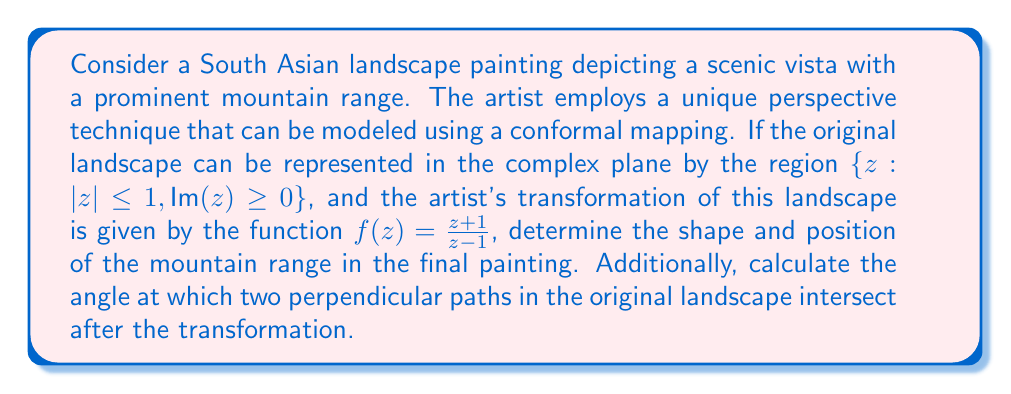Provide a solution to this math problem. To analyze this problem, we'll follow these steps:

1) First, let's understand the original region:
   $\{z: |z| \leq 1, \text{Im}(z) \geq 0\}$ represents the upper half of the unit circle in the complex plane.

2) The conformal mapping $f(z) = \frac{z+1}{z-1}$ is a Möbius transformation. This transformation has some key properties:
   - It maps circles and lines to circles or lines.
   - It preserves angles between curves.

3) To determine the shape of the transformed region, we need to map key points:
   - The point $z=i$ maps to $f(i) = \frac{i+1}{i-1} = i$
   - The point $z=-1$ maps to $f(-1) = 0$
   - The point $z=1$ maps to $f(1) = \infty$

4) The semicircle $|z|=1$ in the upper half-plane maps to the imaginary axis from 0 to $\infty$.

5) The diameter of the semicircle on the real axis from -1 to 1 maps to the entire real axis.

6) Therefore, the transformed region is the right half-plane, $\{w: \text{Re}(w) > 0\}$.

7) In the context of the painting, this means the mountain range (originally represented by the semicircle) becomes a straight vertical line in the transformed perspective.

8) For the angle calculation, we can use the fact that Möbius transformations preserve angles. Therefore, two perpendicular paths in the original landscape will remain perpendicular after the transformation.

[asy]
import geometry;

size(200);
draw(circle((0,0),1),blue);
draw((-1,0)--(1,0),blue);
label("Original", (0,-1.2), blue);

draw((3,0)--(5,2),red);
draw((3,0)--(5,-2),red);
draw((4,-2)--(4,2),red);
label("Transformed", (4,-2.2), red);

draw((-1,0)--(1,0)--(0,1)--cycle,green);
draw((3,0)--(5,0)--(4,1)--cycle,green);
label("90°", (0.3,0.3), green);
label("90°", (4.3,0.3), green);
[/asy]
Answer: The mountain range in the final painting is represented by a straight vertical line along the imaginary axis. The angle between two originally perpendicular paths remains 90° after the transformation. 